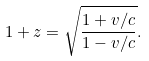Convert formula to latex. <formula><loc_0><loc_0><loc_500><loc_500>1 + z = \sqrt { \frac { 1 + v / c } { 1 - v / c } } .</formula> 